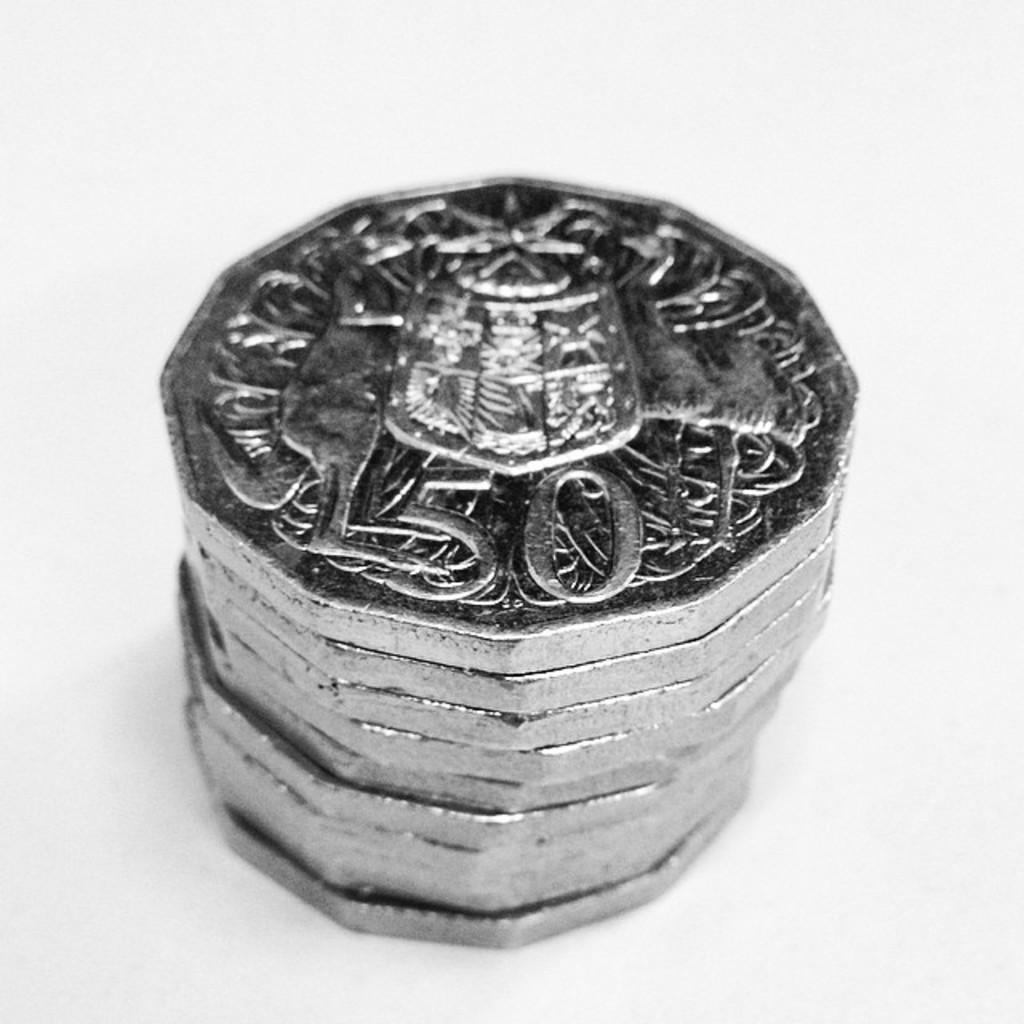<image>
Describe the image concisely. A pile of coins sits on a table with the number 50 visable on the top coin. 